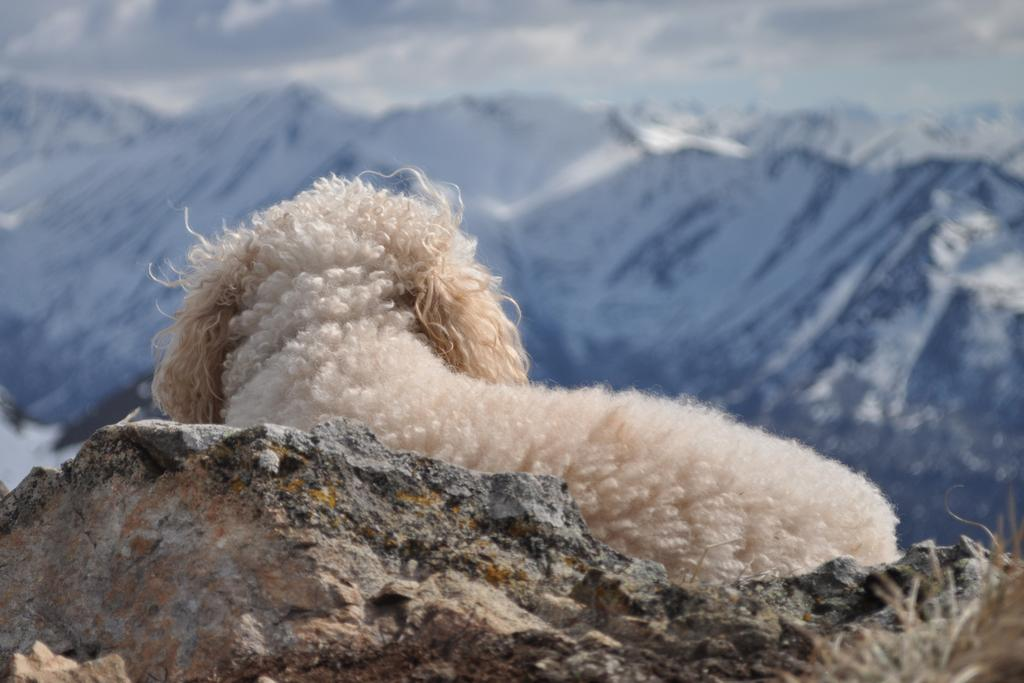What is the main subject in the center of the image? There is an animal in the center of the image. What is located at the bottom of the image? There is a rock at the bottom of the image. What can be seen in the distance in the image? There are mountains visible in the background of the image. What type of alarm is going off in the image? There is no alarm present in the image. How does the rifle affect the animal in the image? There is no rifle present in the image, so it does not affect the animal. 